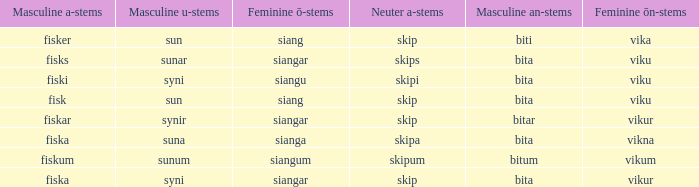What is the masculine form of the word that has a feminine "ö" ending in "siangar" and a masculine "u" ending in "sunar"? Bita. 